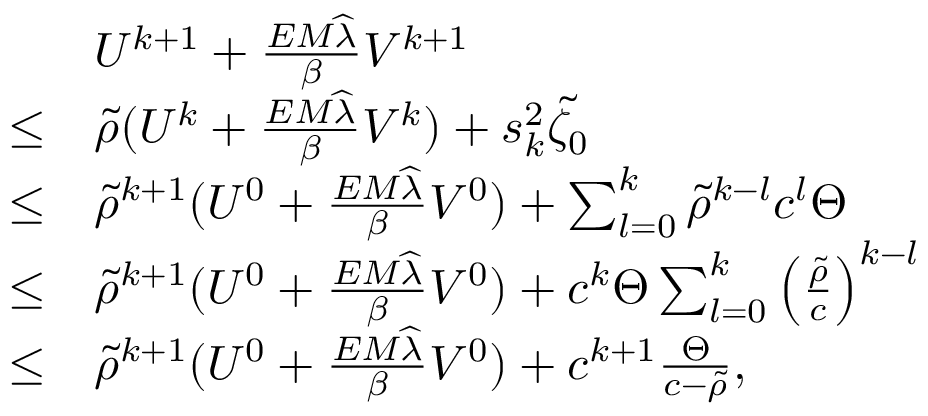<formula> <loc_0><loc_0><loc_500><loc_500>\begin{array} { r l } & { U ^ { k + 1 } + \frac { E M \widehat { \lambda } } { \beta } V ^ { k + 1 } } \\ { \leq } & { \tilde { \rho } ( U ^ { k } + \frac { E M \widehat { \lambda } } { \beta } V ^ { k } ) + s _ { k } ^ { 2 } \tilde { \zeta _ { 0 } } } \\ { \leq } & { \tilde { \rho } ^ { k + 1 } ( U ^ { 0 } + \frac { E M \widehat { \lambda } } { \beta } V ^ { 0 } ) + \sum _ { l = 0 } ^ { k } \tilde { \rho } ^ { k - l } c ^ { l } \Theta } \\ { \leq } & { \tilde { \rho } ^ { k + 1 } ( U ^ { 0 } + \frac { E M \widehat { \lambda } } { \beta } V ^ { 0 } ) + c ^ { k } \Theta \sum _ { l = 0 } ^ { k } \left ( \frac { \tilde { \rho } } { c } \right ) ^ { k - l } } \\ { \leq } & { \tilde { \rho } ^ { k + 1 } ( U ^ { 0 } + \frac { E M \widehat { \lambda } } { \beta } V ^ { 0 } ) + c ^ { k + 1 } \frac { \Theta } { c - \tilde { \rho } } , } \end{array}</formula> 